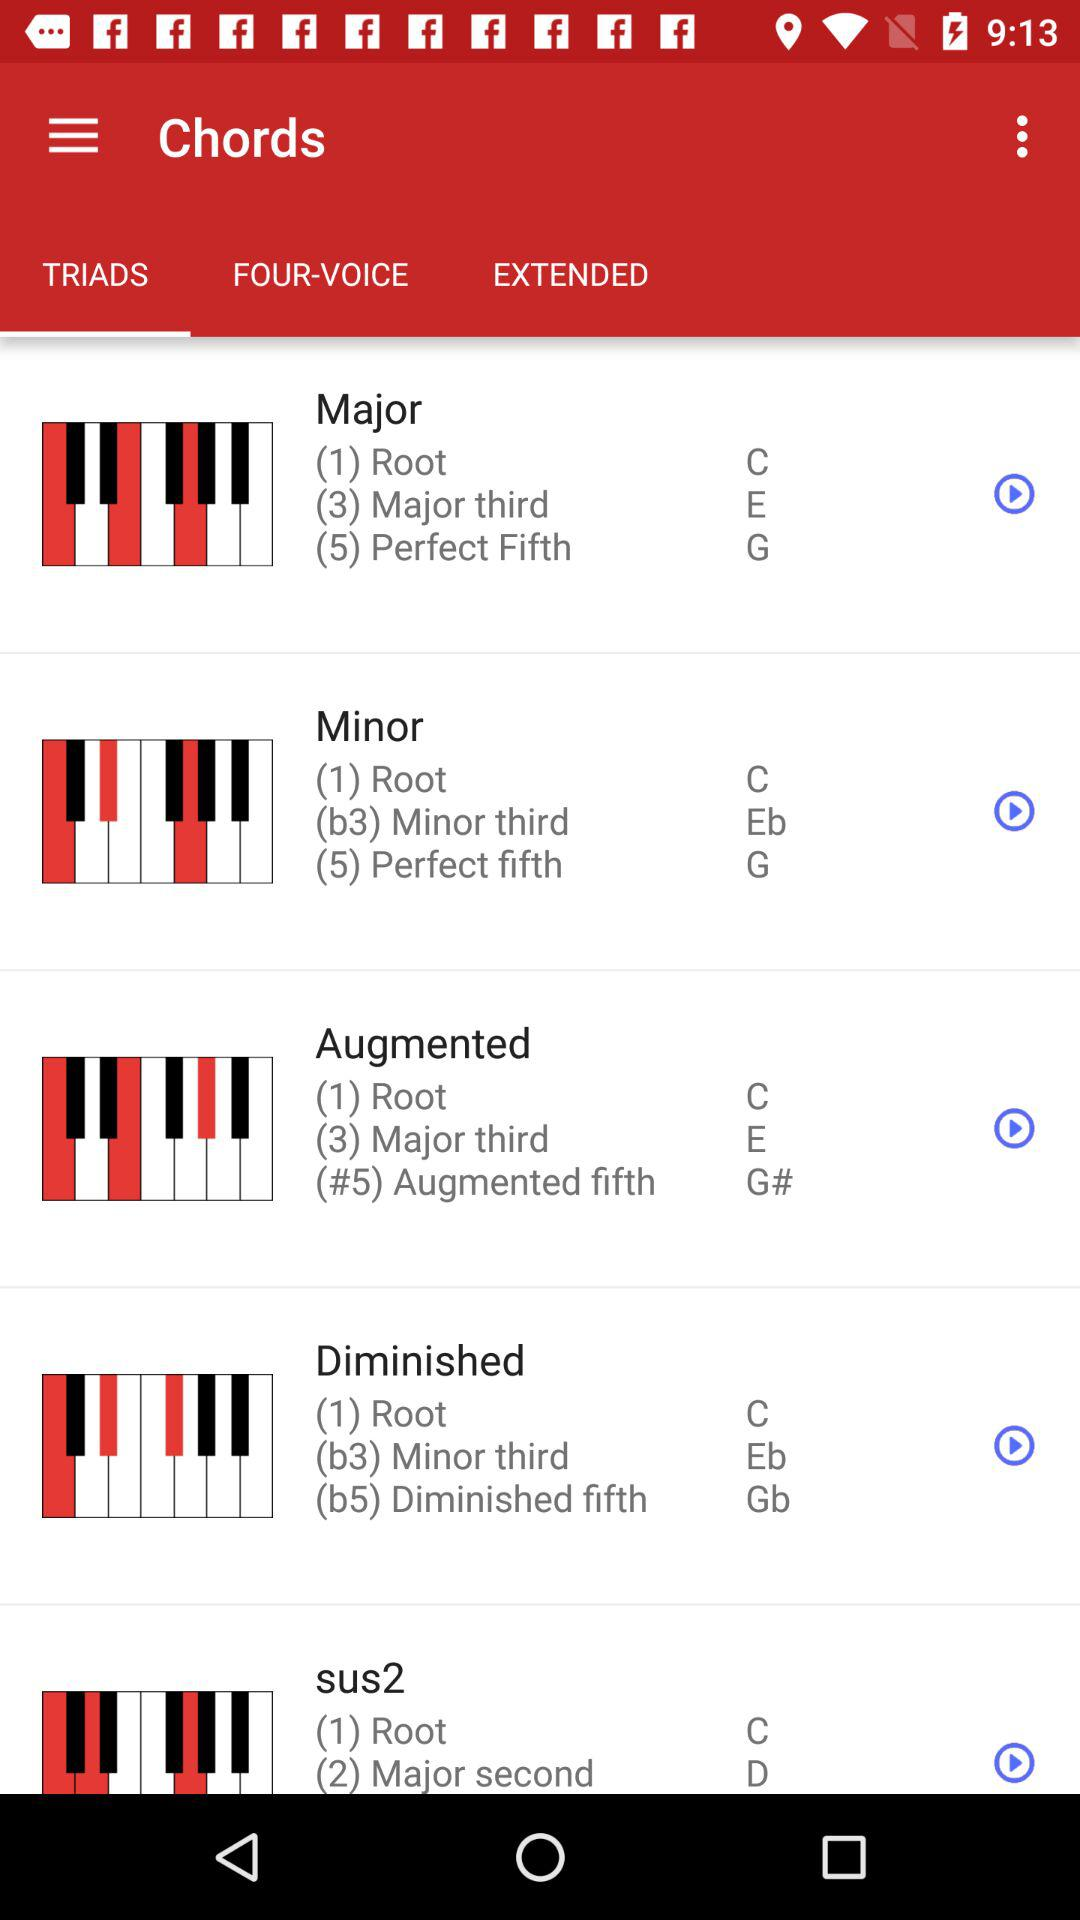How many types of chords are there?
Answer the question using a single word or phrase. 5 